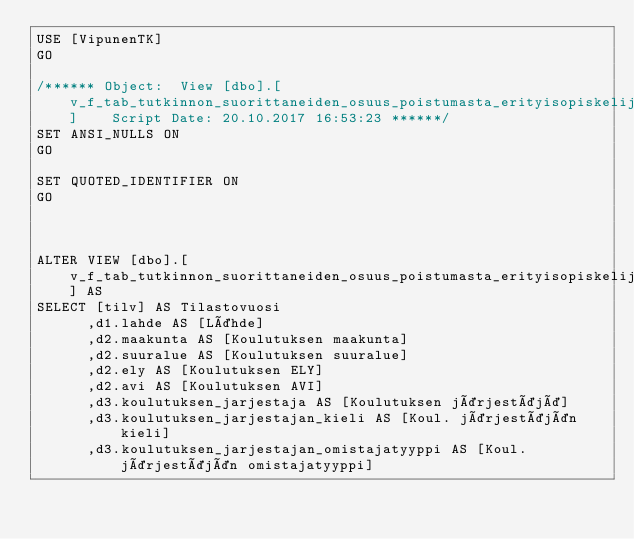Convert code to text. <code><loc_0><loc_0><loc_500><loc_500><_SQL_>USE [VipunenTK]
GO

/****** Object:  View [dbo].[v_f_tab_tutkinnon_suorittaneiden_osuus_poistumasta_erityisopiskelijat]    Script Date: 20.10.2017 16:53:23 ******/
SET ANSI_NULLS ON
GO

SET QUOTED_IDENTIFIER ON
GO



ALTER VIEW [dbo].[v_f_tab_tutkinnon_suorittaneiden_osuus_poistumasta_erityisopiskelijat] AS
SELECT [tilv] AS Tilastovuosi
      ,d1.lahde AS [Lähde]
	  ,d2.maakunta AS [Koulutuksen maakunta]
	  ,d2.suuralue AS [Koulutuksen suuralue]
	  ,d2.ely AS [Koulutuksen ELY]
	  ,d2.avi AS [Koulutuksen AVI]
      ,d3.koulutuksen_jarjestaja AS [Koulutuksen järjestäjä]
	  ,d3.koulutuksen_jarjestajan_kieli AS [Koul. järjestäjän kieli]
	  ,d3.koulutuksen_jarjestajan_omistajatyyppi AS [Koul. järjestäjän omistajatyyppi]</code> 